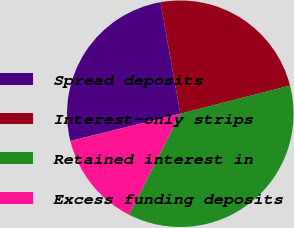Convert chart to OTSL. <chart><loc_0><loc_0><loc_500><loc_500><pie_chart><fcel>Spread deposits<fcel>Interest-only strips<fcel>Retained interest in<fcel>Excess funding deposits<nl><fcel>26.07%<fcel>23.79%<fcel>36.49%<fcel>13.65%<nl></chart> 